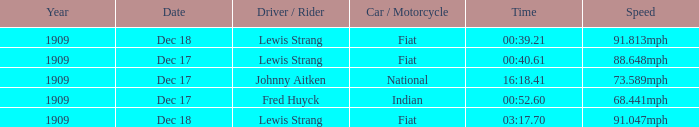What car/motorcycle goes 91.813mph? Fiat. 